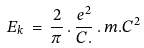Convert formula to latex. <formula><loc_0><loc_0><loc_500><loc_500>\, E _ { k } \, = \, \frac { 2 } { \pi } \, . \, \frac { e ^ { 2 } } { C . } \, . \, m . C ^ { 2 }</formula> 